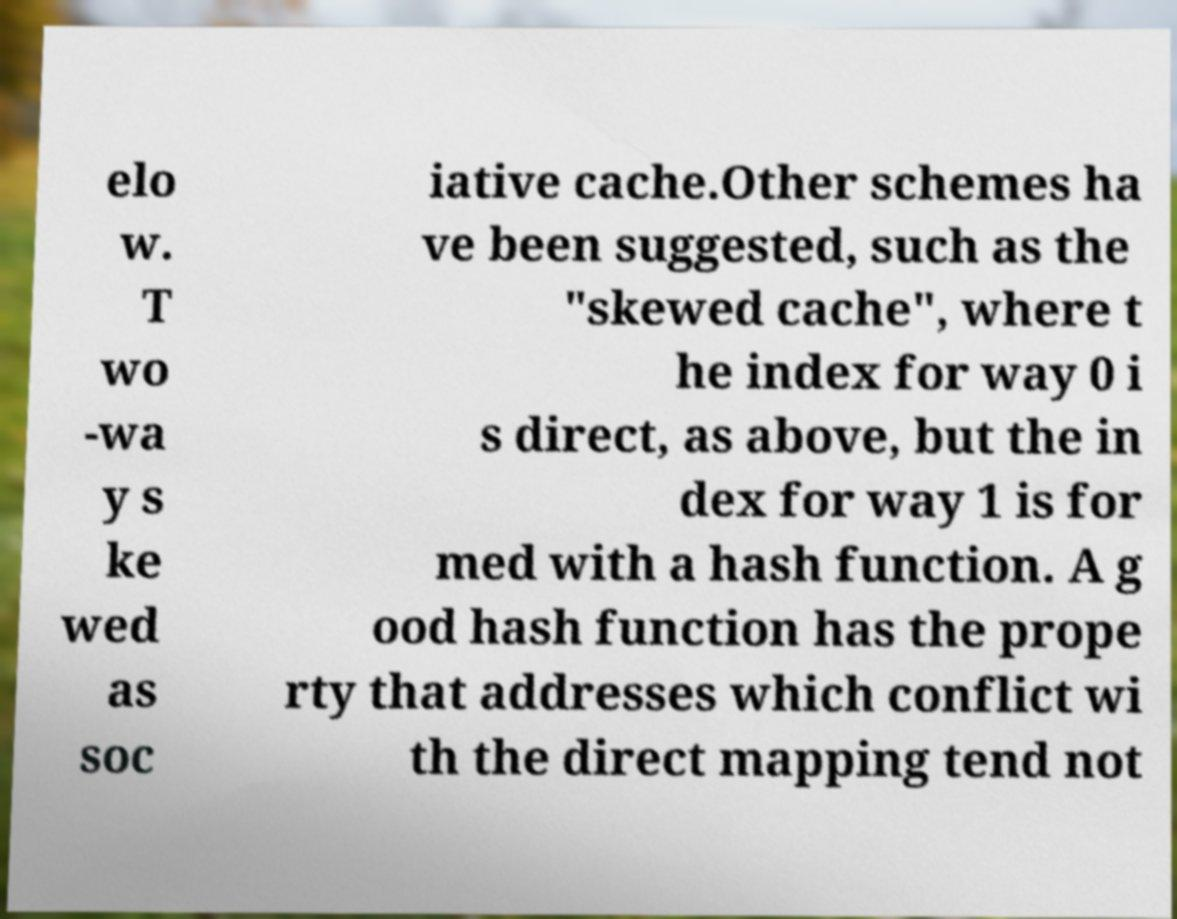Could you assist in decoding the text presented in this image and type it out clearly? elo w. T wo -wa y s ke wed as soc iative cache.Other schemes ha ve been suggested, such as the "skewed cache", where t he index for way 0 i s direct, as above, but the in dex for way 1 is for med with a hash function. A g ood hash function has the prope rty that addresses which conflict wi th the direct mapping tend not 